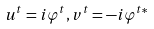Convert formula to latex. <formula><loc_0><loc_0><loc_500><loc_500>u ^ { t } = i \varphi ^ { t } , v ^ { t } = - i \varphi ^ { t * }</formula> 